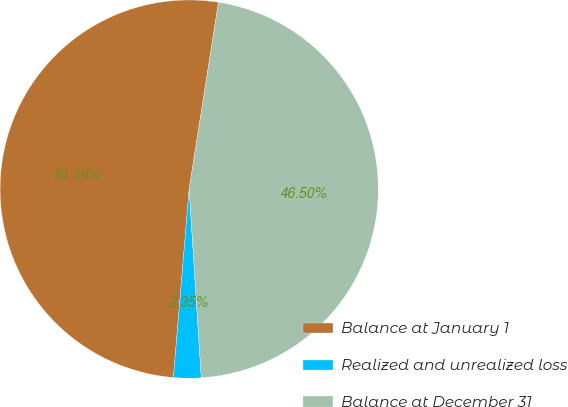Convert chart to OTSL. <chart><loc_0><loc_0><loc_500><loc_500><pie_chart><fcel>Balance at January 1<fcel>Realized and unrealized loss<fcel>Balance at December 31<nl><fcel>51.15%<fcel>2.35%<fcel>46.5%<nl></chart> 